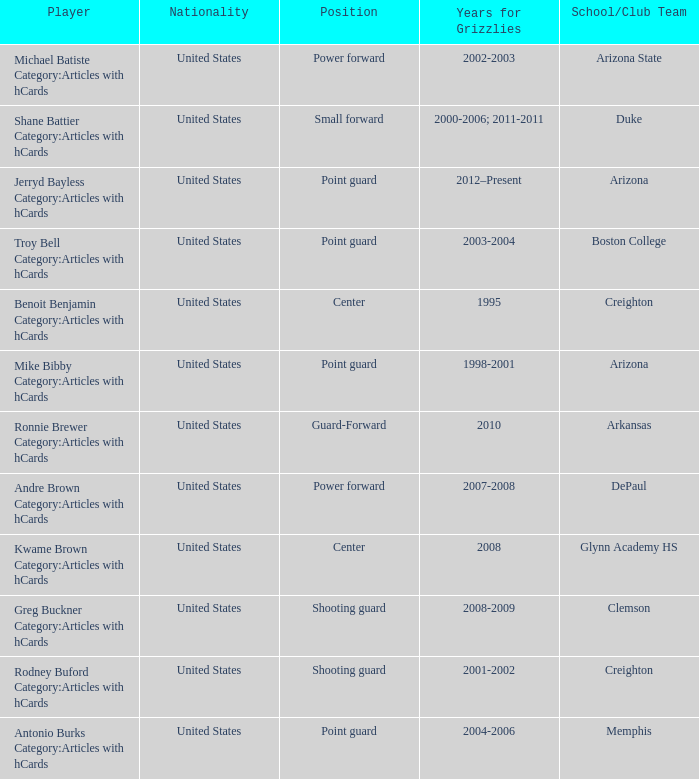Who is the power forward player representing the depaul school/club team? Andre Brown Category:Articles with hCards. 